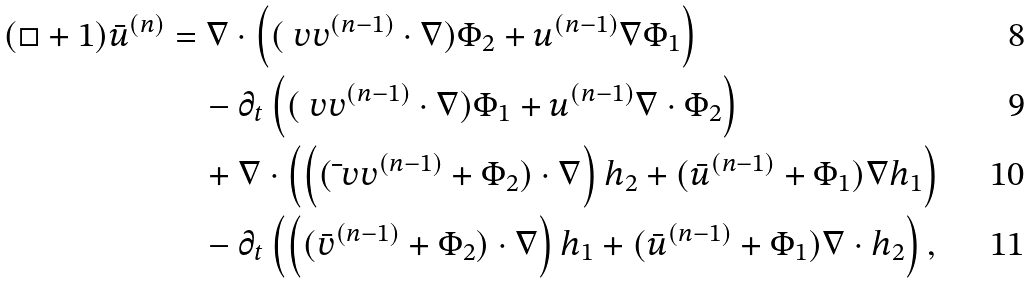<formula> <loc_0><loc_0><loc_500><loc_500>( \square + 1 ) \bar { u } ^ { ( n ) } & = \nabla \cdot \left ( ( \ v v ^ { ( n - 1 ) } \cdot \nabla ) \Phi _ { 2 } + u ^ { ( n - 1 ) } \nabla \Phi _ { 1 } \right ) \\ & \quad - \partial _ { t } \left ( ( \ v v ^ { ( n - 1 ) } \cdot \nabla ) \Phi _ { 1 } + u ^ { ( n - 1 ) } \nabla \cdot \Phi _ { 2 } \right ) \\ & \quad + \nabla \cdot \left ( \left ( ( \bar { \ } v v ^ { ( n - 1 ) } + \Phi _ { 2 } ) \cdot \nabla \right ) h _ { 2 } + ( \bar { u } ^ { ( n - 1 ) } + \Phi _ { 1 } ) \nabla h _ { 1 } \right ) \\ & \quad - \partial _ { t } \left ( \left ( ( \bar { v } ^ { ( n - 1 ) } + \Phi _ { 2 } ) \cdot \nabla \right ) h _ { 1 } + ( \bar { u } ^ { ( n - 1 ) } + \Phi _ { 1 } ) \nabla \cdot h _ { 2 } \right ) ,</formula> 